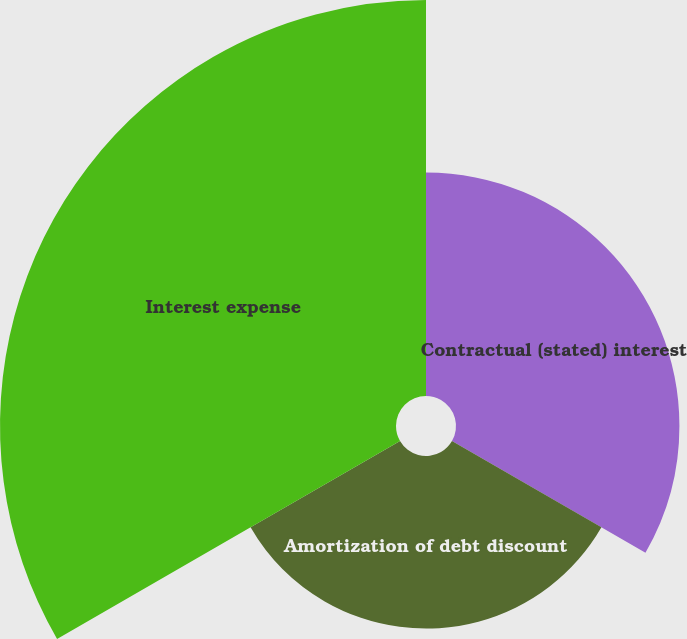Convert chart. <chart><loc_0><loc_0><loc_500><loc_500><pie_chart><fcel>Contractual (stated) interest<fcel>Amortization of debt discount<fcel>Interest expense<nl><fcel>28.21%<fcel>21.79%<fcel>50.0%<nl></chart> 